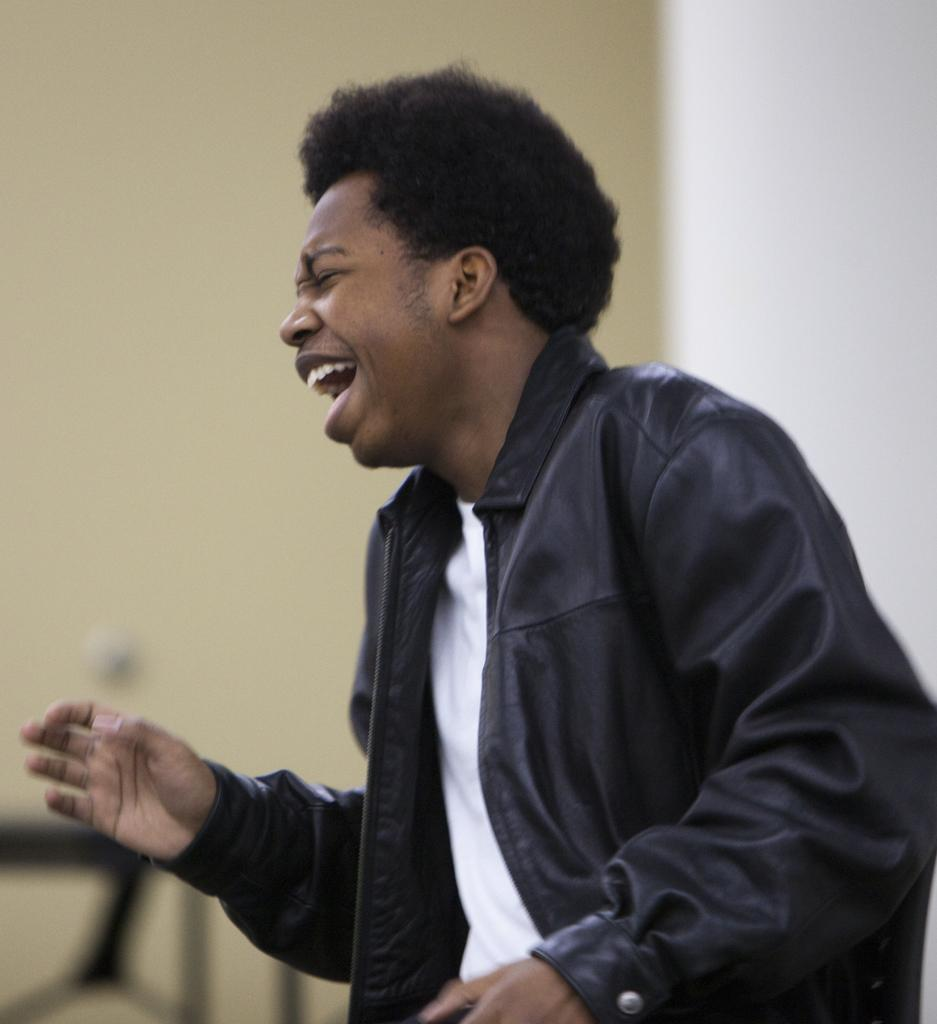Who is present in the image? There is a man in the image. What is the man doing in the image? The man is standing in the image. What expression does the man have in the image? The man is smiling in the image. What can be seen in the background of the image? There is a wall in the background of the image. What type of rose can be seen in the man's hand in the image? There is no rose present in the image; the man is not holding anything. 